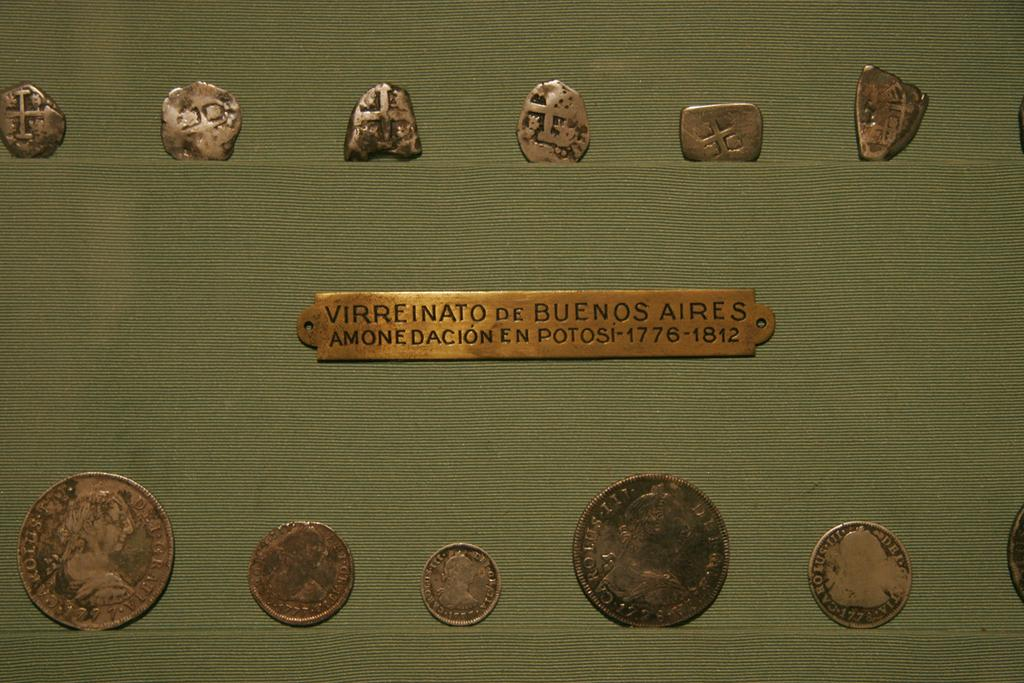<image>
Render a clear and concise summary of the photo. Several coins from Buenos Aires are displayed in two rows. 